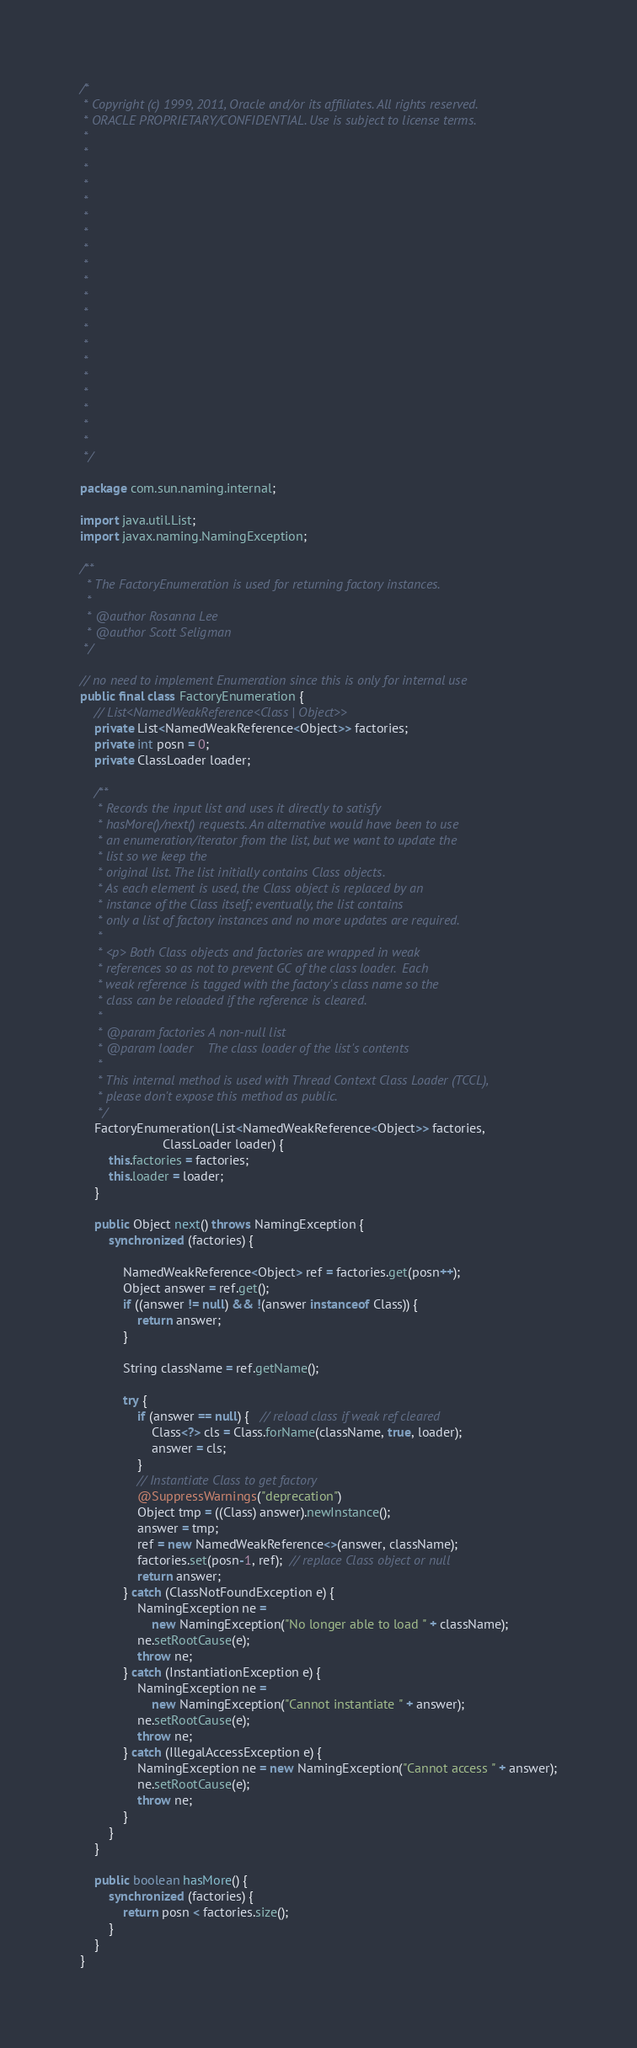Convert code to text. <code><loc_0><loc_0><loc_500><loc_500><_Java_>/*
 * Copyright (c) 1999, 2011, Oracle and/or its affiliates. All rights reserved.
 * ORACLE PROPRIETARY/CONFIDENTIAL. Use is subject to license terms.
 *
 *
 *
 *
 *
 *
 *
 *
 *
 *
 *
 *
 *
 *
 *
 *
 *
 *
 *
 *
 */

package com.sun.naming.internal;

import java.util.List;
import javax.naming.NamingException;

/**
  * The FactoryEnumeration is used for returning factory instances.
  *
  * @author Rosanna Lee
  * @author Scott Seligman
 */

// no need to implement Enumeration since this is only for internal use
public final class FactoryEnumeration {
    // List<NamedWeakReference<Class | Object>>
    private List<NamedWeakReference<Object>> factories;
    private int posn = 0;
    private ClassLoader loader;

    /**
     * Records the input list and uses it directly to satisfy
     * hasMore()/next() requests. An alternative would have been to use
     * an enumeration/iterator from the list, but we want to update the
     * list so we keep the
     * original list. The list initially contains Class objects.
     * As each element is used, the Class object is replaced by an
     * instance of the Class itself; eventually, the list contains
     * only a list of factory instances and no more updates are required.
     *
     * <p> Both Class objects and factories are wrapped in weak
     * references so as not to prevent GC of the class loader.  Each
     * weak reference is tagged with the factory's class name so the
     * class can be reloaded if the reference is cleared.
     *
     * @param factories A non-null list
     * @param loader    The class loader of the list's contents
     *
     * This internal method is used with Thread Context Class Loader (TCCL),
     * please don't expose this method as public.
     */
    FactoryEnumeration(List<NamedWeakReference<Object>> factories,
                       ClassLoader loader) {
        this.factories = factories;
        this.loader = loader;
    }

    public Object next() throws NamingException {
        synchronized (factories) {

            NamedWeakReference<Object> ref = factories.get(posn++);
            Object answer = ref.get();
            if ((answer != null) && !(answer instanceof Class)) {
                return answer;
            }

            String className = ref.getName();

            try {
                if (answer == null) {   // reload class if weak ref cleared
                    Class<?> cls = Class.forName(className, true, loader);
                    answer = cls;
                }
                // Instantiate Class to get factory
                @SuppressWarnings("deprecation")
                Object tmp = ((Class) answer).newInstance();
                answer = tmp;
                ref = new NamedWeakReference<>(answer, className);
                factories.set(posn-1, ref);  // replace Class object or null
                return answer;
            } catch (ClassNotFoundException e) {
                NamingException ne =
                    new NamingException("No longer able to load " + className);
                ne.setRootCause(e);
                throw ne;
            } catch (InstantiationException e) {
                NamingException ne =
                    new NamingException("Cannot instantiate " + answer);
                ne.setRootCause(e);
                throw ne;
            } catch (IllegalAccessException e) {
                NamingException ne = new NamingException("Cannot access " + answer);
                ne.setRootCause(e);
                throw ne;
            }
        }
    }

    public boolean hasMore() {
        synchronized (factories) {
            return posn < factories.size();
        }
    }
}
</code> 